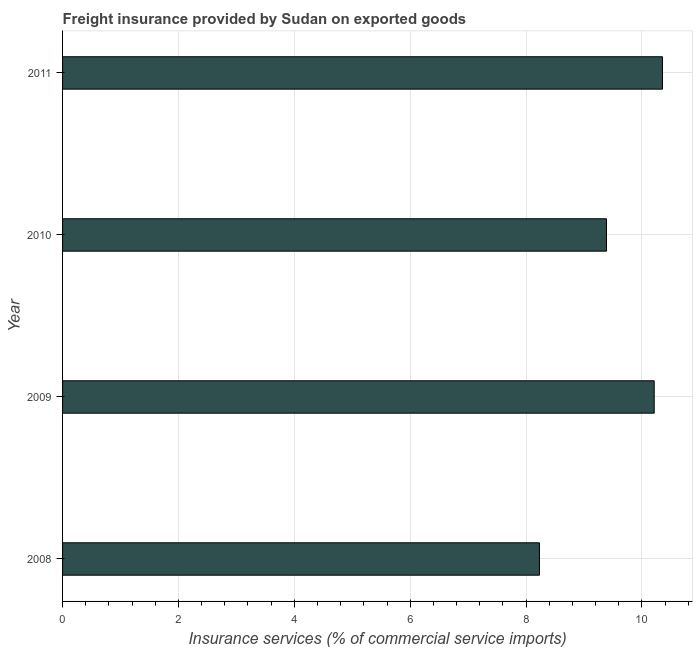Does the graph contain grids?
Your response must be concise. Yes. What is the title of the graph?
Make the answer very short. Freight insurance provided by Sudan on exported goods . What is the label or title of the X-axis?
Provide a short and direct response. Insurance services (% of commercial service imports). What is the freight insurance in 2009?
Give a very brief answer. 10.21. Across all years, what is the maximum freight insurance?
Ensure brevity in your answer.  10.36. Across all years, what is the minimum freight insurance?
Keep it short and to the point. 8.23. In which year was the freight insurance maximum?
Your answer should be very brief. 2011. What is the sum of the freight insurance?
Offer a very short reply. 38.19. What is the difference between the freight insurance in 2009 and 2010?
Ensure brevity in your answer.  0.82. What is the average freight insurance per year?
Your answer should be compact. 9.55. What is the median freight insurance?
Keep it short and to the point. 9.8. In how many years, is the freight insurance greater than 7.6 %?
Ensure brevity in your answer.  4. Do a majority of the years between 2008 and 2009 (inclusive) have freight insurance greater than 9.6 %?
Offer a very short reply. No. What is the ratio of the freight insurance in 2008 to that in 2009?
Provide a succinct answer. 0.81. What is the difference between the highest and the second highest freight insurance?
Your answer should be compact. 0.14. Is the sum of the freight insurance in 2009 and 2010 greater than the maximum freight insurance across all years?
Give a very brief answer. Yes. What is the difference between the highest and the lowest freight insurance?
Your answer should be compact. 2.12. In how many years, is the freight insurance greater than the average freight insurance taken over all years?
Your answer should be compact. 2. Are the values on the major ticks of X-axis written in scientific E-notation?
Your answer should be compact. No. What is the Insurance services (% of commercial service imports) in 2008?
Offer a very short reply. 8.23. What is the Insurance services (% of commercial service imports) of 2009?
Your response must be concise. 10.21. What is the Insurance services (% of commercial service imports) of 2010?
Your answer should be very brief. 9.39. What is the Insurance services (% of commercial service imports) in 2011?
Give a very brief answer. 10.36. What is the difference between the Insurance services (% of commercial service imports) in 2008 and 2009?
Provide a succinct answer. -1.98. What is the difference between the Insurance services (% of commercial service imports) in 2008 and 2010?
Offer a terse response. -1.16. What is the difference between the Insurance services (% of commercial service imports) in 2008 and 2011?
Provide a short and direct response. -2.12. What is the difference between the Insurance services (% of commercial service imports) in 2009 and 2010?
Provide a short and direct response. 0.82. What is the difference between the Insurance services (% of commercial service imports) in 2009 and 2011?
Provide a short and direct response. -0.14. What is the difference between the Insurance services (% of commercial service imports) in 2010 and 2011?
Ensure brevity in your answer.  -0.97. What is the ratio of the Insurance services (% of commercial service imports) in 2008 to that in 2009?
Your response must be concise. 0.81. What is the ratio of the Insurance services (% of commercial service imports) in 2008 to that in 2010?
Your answer should be very brief. 0.88. What is the ratio of the Insurance services (% of commercial service imports) in 2008 to that in 2011?
Your answer should be very brief. 0.8. What is the ratio of the Insurance services (% of commercial service imports) in 2009 to that in 2010?
Offer a terse response. 1.09. What is the ratio of the Insurance services (% of commercial service imports) in 2009 to that in 2011?
Offer a terse response. 0.99. What is the ratio of the Insurance services (% of commercial service imports) in 2010 to that in 2011?
Provide a succinct answer. 0.91. 